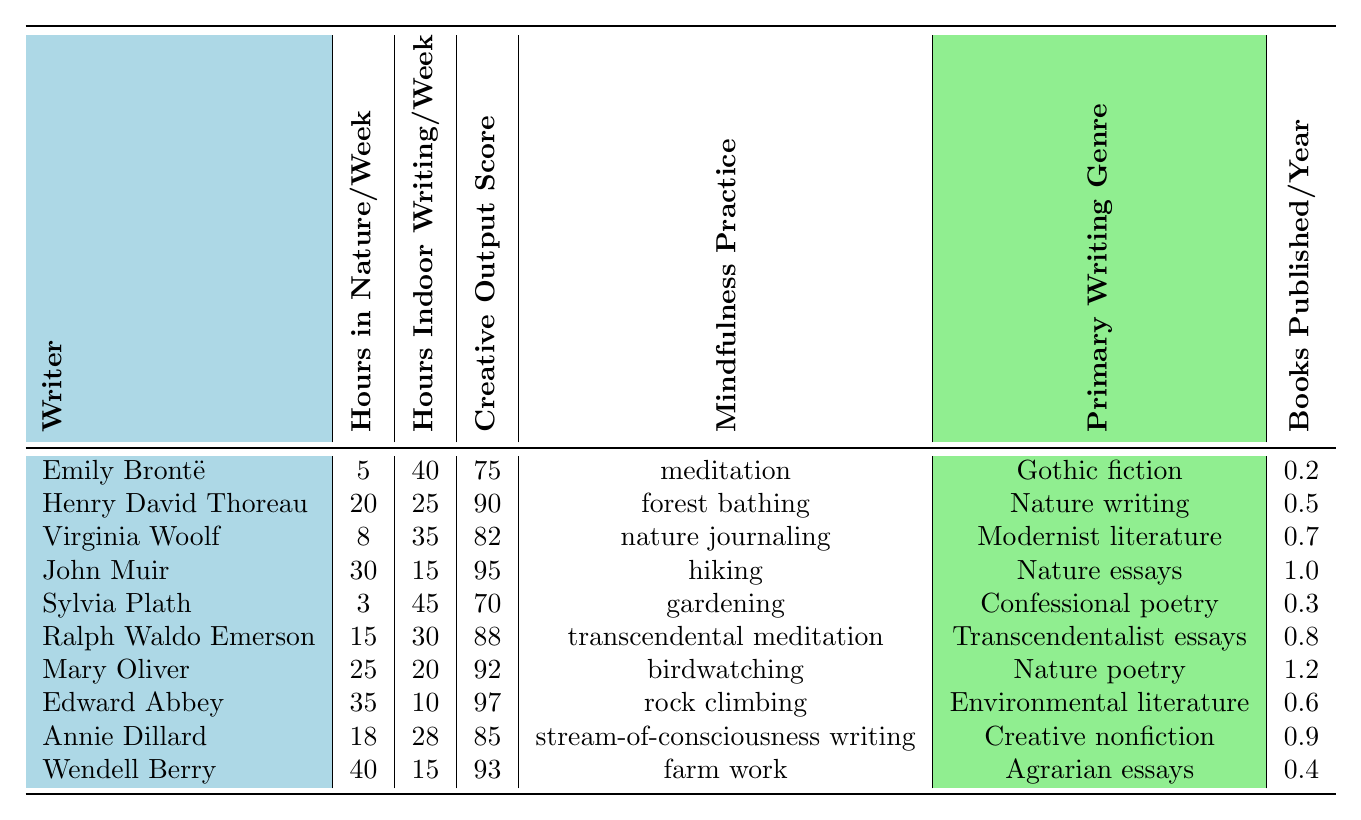What is the highest creative output score among the writers? The creative output scores are listed in the table. The highest score is 97, which belongs to Edward Abbey.
Answer: 97 How many hours, on average, do the writers spend indoors writing per week? To find the average, sum the hours spent writing indoors: (40 + 25 + 35 + 15 + 45 + 30 + 20 + 10 + 28 + 15) = 358. Then divide by the number of writers (10): 358 / 10 = 35.8.
Answer: 35.8 Which writer spends the most hours in nature per week? The table lists the hours in nature for each writer. Edward Abbey spends the most time, with 35 hours in nature per week.
Answer: Edward Abbey Is there a writer who has the same number of hours in nature and indoor writing combined? Calculate the total hours for each writer by adding hours in nature and hours of indoor writing: Edward Abbey (35+10), John Muir (30+15), and others. Only John Muir has 45 total hours (30 in nature and 15 writing), matching that of Emily Brontë (5 in nature and 40 writing).
Answer: Yes, John Muir and Emily Brontë What is the relationship between hours in nature and creative output score? By comparing the two columns, as the hours in nature increase, the creative output score tends to increase as well, indicating a positive correlation.
Answer: Positive correlation How many books does Mary Oliver publish per year compared to Sylvia Plath? According to the table, Mary Oliver publishes 1.2 books per year while Sylvia Plath publishes 0.3 books per year. The difference is 1.2 - 0.3 = 0.9.
Answer: 0.9 more books per year What mindfulness practice is associated with the highest number of hours in nature? Looking at the table, Edward Abbey has the highest hours in nature (35) and practices rock climbing as his mindfulness practice.
Answer: Rock climbing Which writing genre do writers who spend more than 20 hours in nature predominantly write? Analyzing the writers who spend over 20 hours in nature: John Muir, Mary Oliver, and Edward Abbey primarily write nature essays, nature poetry, and environmental literature, respectively.
Answer: Nature-related genres Are there any writers who have a creative output score below 80? Checking the creative output scores, Emily Brontë (75) and Sylvia Plath (70) both have scores below 80.
Answer: Yes, two writers Which mindfulness practice correlates with the lowest creative output score? By looking at the table, Sylvia Plath practices gardening and has the lowest creative output score of 70.
Answer: Gardening 